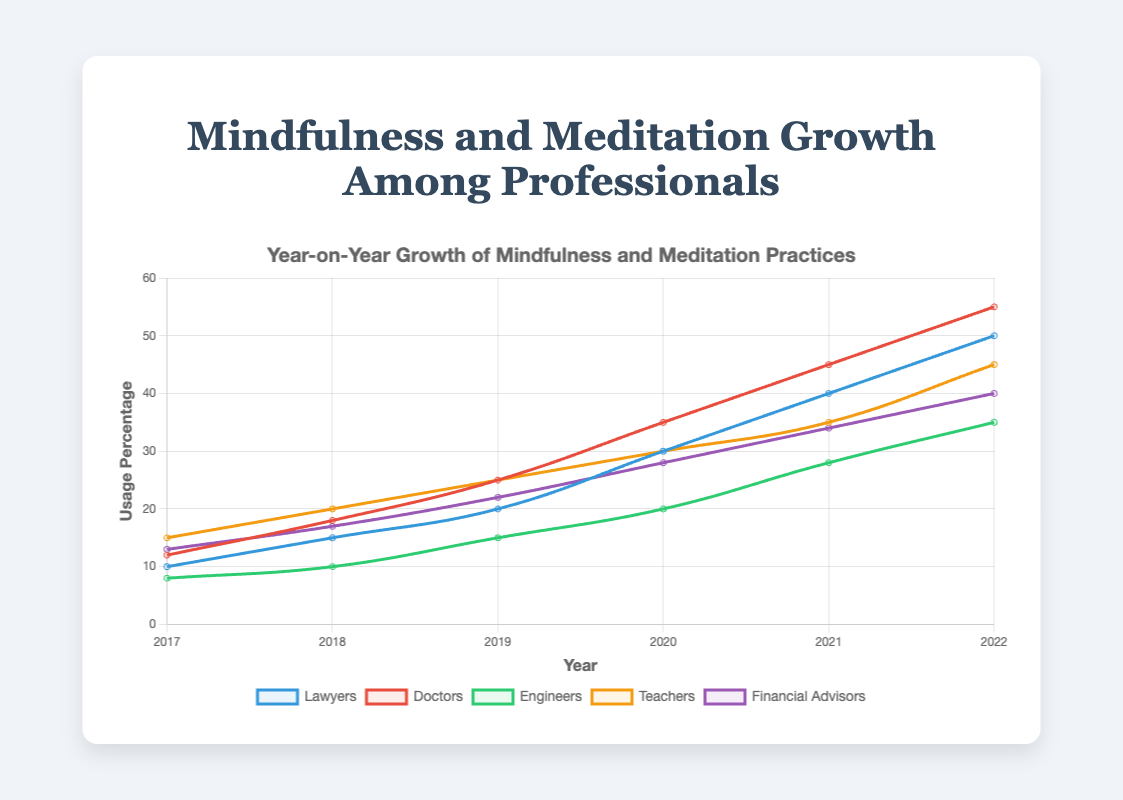Which profession had the highest percentage of mindfulness and meditation practice in 2022? Look at the ends of the lines (2022) and identify the profession corresponding to the highest point on the y-axis. The point for Doctors reaches 55%.
Answer: Doctors By how much did the percentage of meditation practice increase for Lawyers from 2017 to 2022? Find the difference between the 2022 and 2017 values for Lawyers: 50% - 10% = 40%.
Answer: 40% Which year saw the greatest increase in meditation practice for Teachers? Identify the years with the largest differences in Teachers' percentages: 2017 (15%) to 2018 (20%) increase by 5, 2018 to 2019 increase by 5, 2019 to 2020 increase by 5, 2020 to 2021 increase by 5, 2021 to 2022 increase by 10. Therefore, the largest increase occurred from 2021 to 2022.
Answer: 2021-2022 Compare the usage percentage between Engineers and Financial Advisors in 2019. Which group had a higher percentage? Look at the 2019 values: Engineers have 15% and Financial Advisors have 22%. Financial Advisors have a higher percentage.
Answer: Financial Advisors What’s the average annual growth rate of mindfulness practice for Doctors between 2017 and 2022? Calculate the annual growth for each year and then find the average: (18-12)/1 + (25-18)/1 + (35-25)/1 + (45-35)/1 + (55-45)/1 = 6+7+10+10+10 = 43. Average = 43/5 = 8.6% per year.
Answer: 8.6% In which year did Financial Advisors surpass Teachers in meditation practice usage? Identify when the line for Financial Advisors crosses above the line for Teachers by checking the values year by year: 2019 (22% for Financial Advisors and 25% for Teachers), 2020 (28% for Financial Advisors and 30% for Teachers), 2021 (34% for Financial Advisors and 35% for Teachers), 2022 (40% for Financial Advisors and 45% for Teachers). Financial Advisors never surpassed Teachers during these years.
Answer: Never Which profession had the least growth rate in meditation practice over the entire period from 2017 to 2022? Calculate the growth as the difference between the 2022 and 2017 value for each profession: Lawyers 50-10=40, Doctors 55-12=43, Engineers 35-8=27, Teachers 45-15=30, Financial Advisors 40-13=27. Engineers and Financial Advisors both increased by 27%.
Answer: Engineers and Financial Advisors What is the percentage difference in usage between the profession with the highest and lowest mindfulness practice in 2020? Identify the highest and lowest points for 2020: Doctors (35%) and Engineers (20%). Difference: 35%-20% = 15%.
Answer: 15% What's the median usage percentage for meditation practice among all professions in 2021? Arrange the 2021 values in ascending order: 28%, 34%, 35%, 40%, 45%. The middle value (median) is Financial Advisors at 34%.
Answer: 34% 